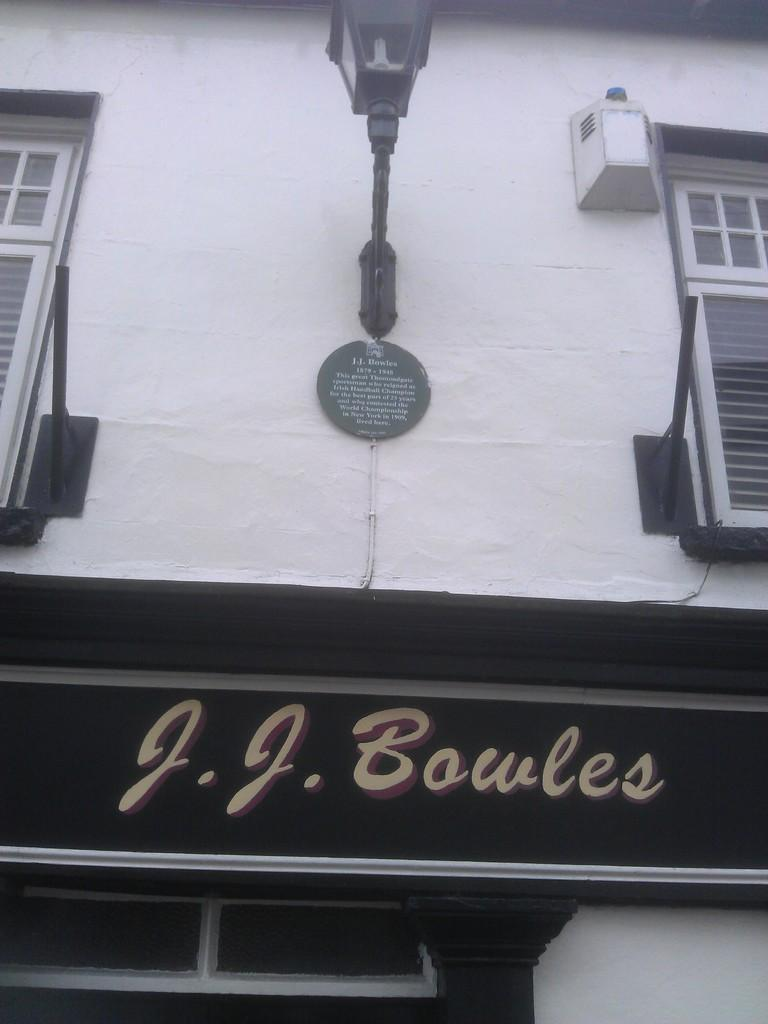What type of structure is present in the image? There is a building in the image. What is the color of the building? The building is white. What can be seen in the background of the image? There are lights and windows visible in the background. What is the black object in the image? There is a black color board in the image. Can you see the ocean or seashore in the image? No, there is no ocean or seashore visible in the image. Is there a team of people present in the image? No, there is no team of people present in the image. 